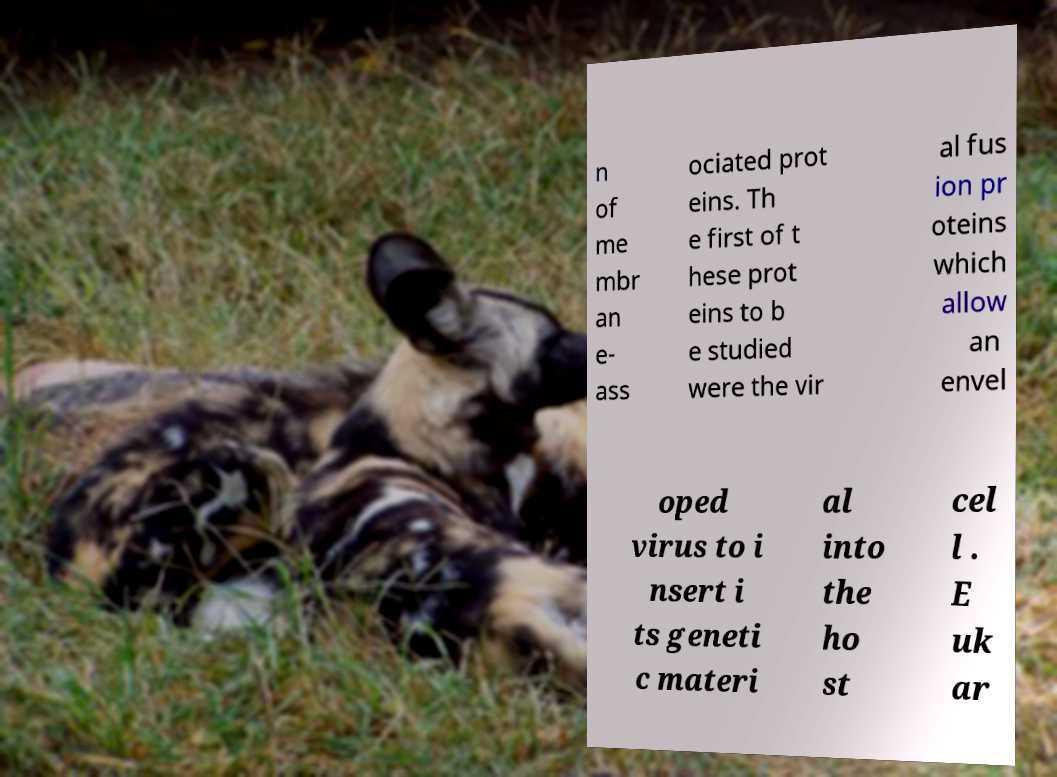I need the written content from this picture converted into text. Can you do that? n of me mbr an e- ass ociated prot eins. Th e first of t hese prot eins to b e studied were the vir al fus ion pr oteins which allow an envel oped virus to i nsert i ts geneti c materi al into the ho st cel l . E uk ar 